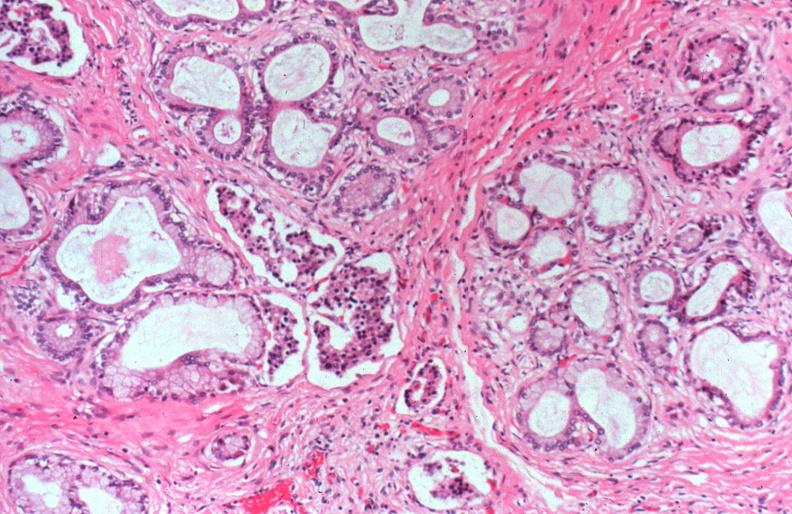what does this image show?
Answer the question using a single word or phrase. Cystic fibrosis 